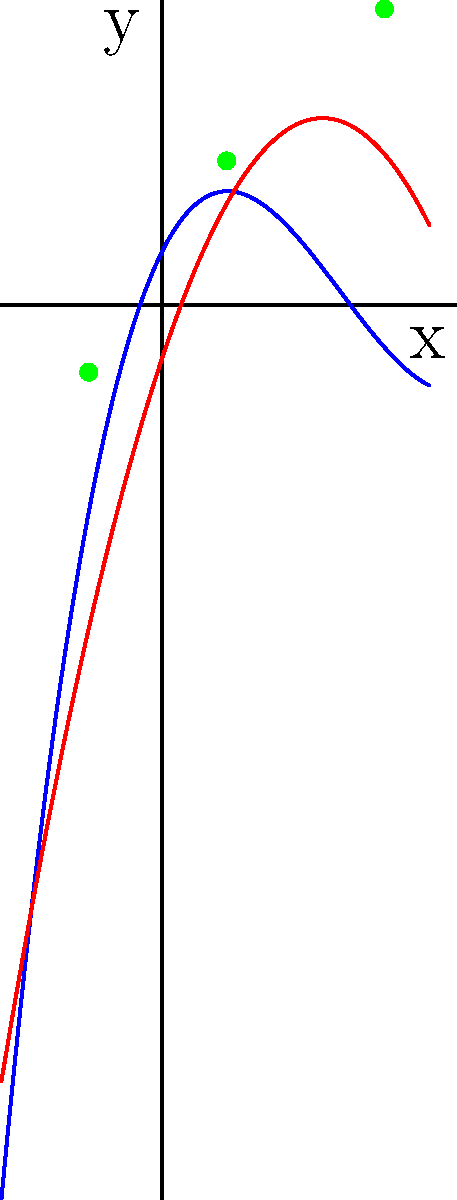As a self-published writer aiming to make a name in the genre, you're exploring mathematical concepts for a potential sci-fi novel. You come across two polynomial functions: $P(x) = 0.1x^3 - x^2 + 2x + 1$ and $Q(x) = -0.5x^2 + 3x - 1$. How many times do these functions intersect within the interval $[-3, 5]$? To determine the number of intersections between the two polynomial functions, we need to follow these steps:

1) The intersections occur where $P(x) = Q(x)$. This means we need to solve the equation:

   $0.1x^3 - x^2 + 2x + 1 = -0.5x^2 + 3x - 1$

2) Rearranging the equation:

   $0.1x^3 - 0.5x^2 - x + 2 = 0$

3) This is a cubic equation, which can have up to three real roots. Each root represents an intersection point.

4) From the graph, we can visually confirm that there are indeed three intersection points within the interval $[-3, 5]$.

5) These points are approximately at:
   - $x \approx -1.37$
   - $x \approx 1.21$
   - $x \approx 4.16$

6) The exact values could be calculated using algebraic methods or numerical approximations, but for the purpose of counting intersections, the visual representation is sufficient.

Therefore, the two polynomial functions intersect three times within the given interval.
Answer: 3 